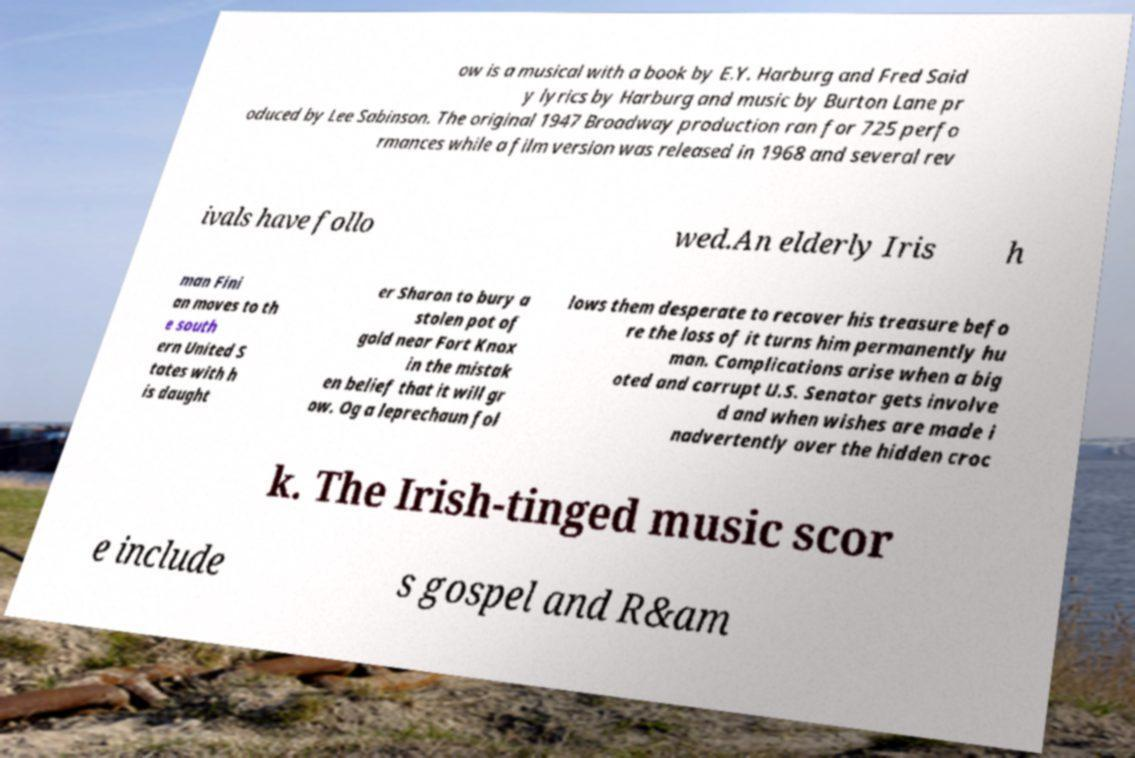What messages or text are displayed in this image? I need them in a readable, typed format. ow is a musical with a book by E.Y. Harburg and Fred Said y lyrics by Harburg and music by Burton Lane pr oduced by Lee Sabinson. The original 1947 Broadway production ran for 725 perfo rmances while a film version was released in 1968 and several rev ivals have follo wed.An elderly Iris h man Fini an moves to th e south ern United S tates with h is daught er Sharon to bury a stolen pot of gold near Fort Knox in the mistak en belief that it will gr ow. Og a leprechaun fol lows them desperate to recover his treasure befo re the loss of it turns him permanently hu man. Complications arise when a big oted and corrupt U.S. Senator gets involve d and when wishes are made i nadvertently over the hidden croc k. The Irish-tinged music scor e include s gospel and R&am 